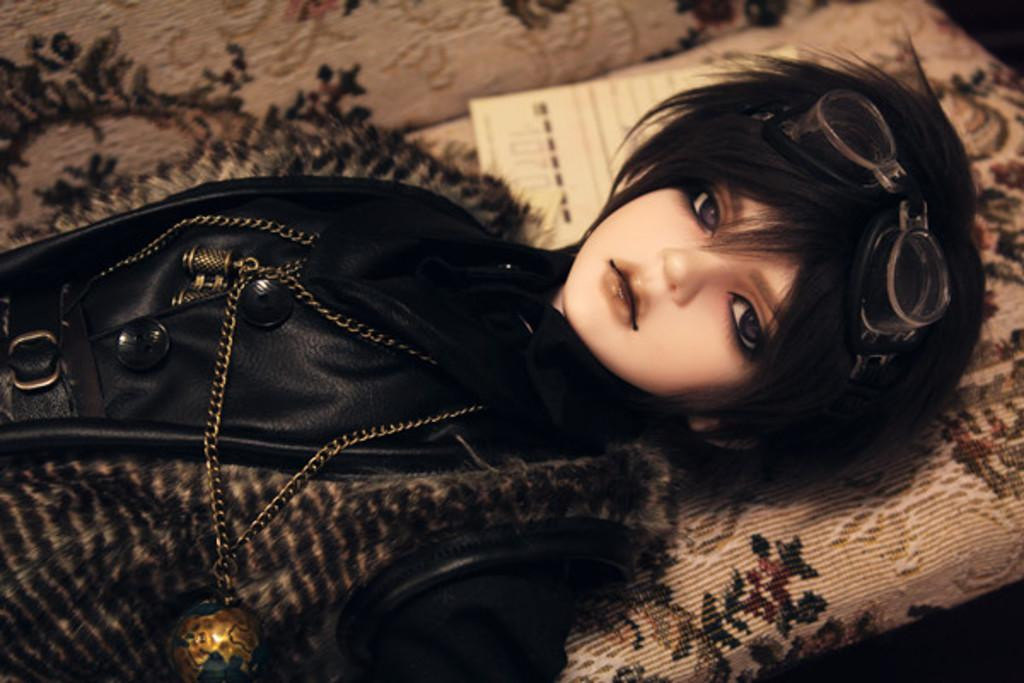What is the main subject of the image? There is a doll in the image. What is the doll wearing? The doll is wearing a black dress and spectacles. Where is the doll located in the image? The doll is laying on a sofa. What type of car can be seen in the image? There is no car present in the image; it features a doll laying on a sofa. How many hearts are visible on the doll's dress? The doll's dress is described as black, and there is no mention of hearts on it. 